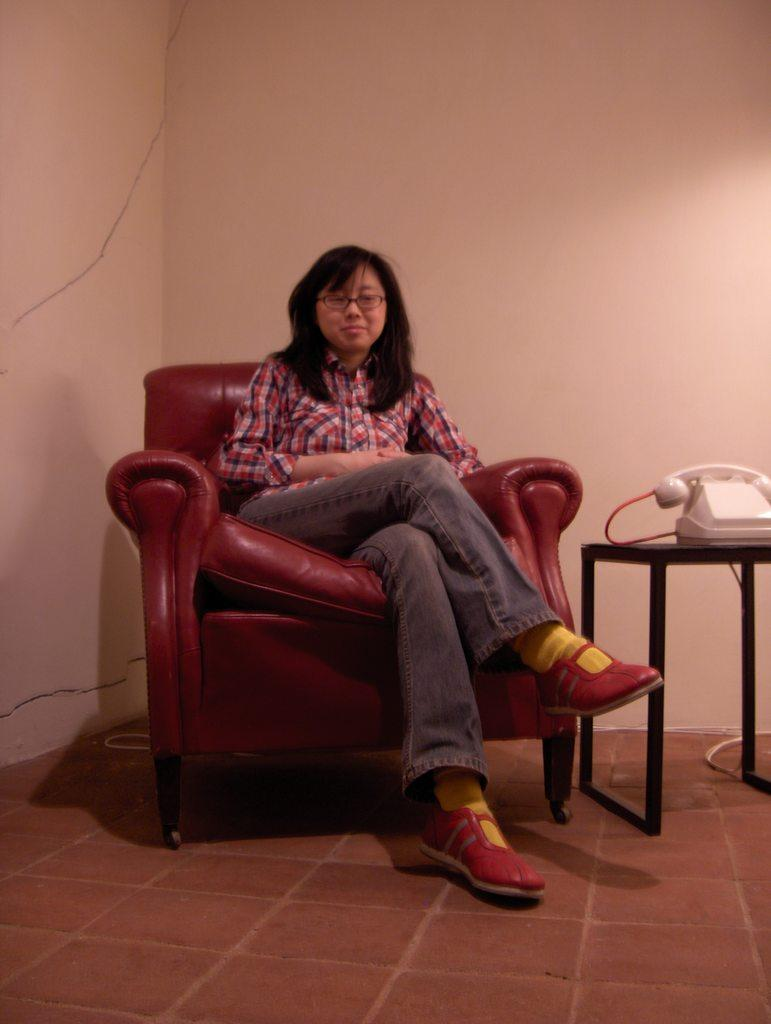Who is present in the image? There is a woman in the image. What is the woman sitting on? The woman is sitting on a red chair. What object can be seen on a table in the image? There is a telephone on a table in the image. What type of library is visible in the background of the image? There is no library visible in the background of the image. 